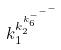Convert formula to latex. <formula><loc_0><loc_0><loc_500><loc_500>k _ { 1 } ^ { k _ { 2 } ^ { k _ { 6 } ^ { - ^ { - ^ { - } } } } }</formula> 